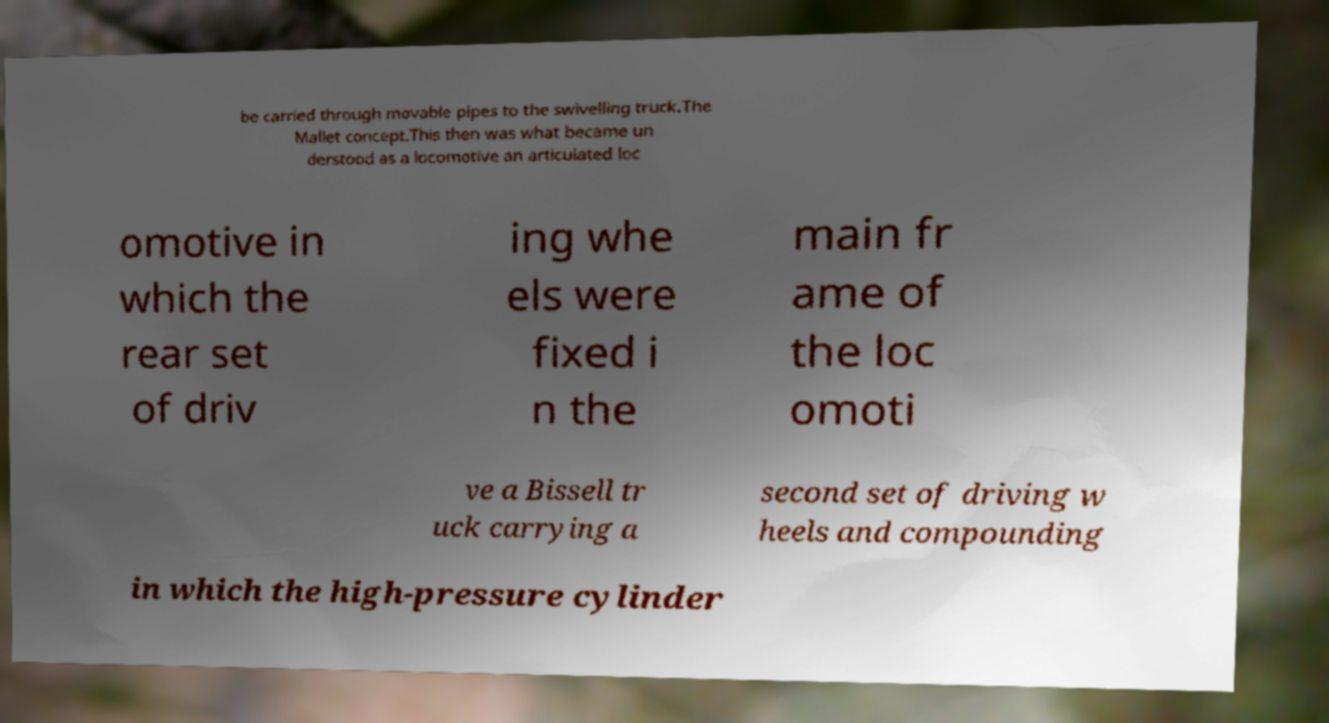Could you extract and type out the text from this image? be carried through movable pipes to the swivelling truck.The Mallet concept.This then was what became un derstood as a locomotive an articulated loc omotive in which the rear set of driv ing whe els were fixed i n the main fr ame of the loc omoti ve a Bissell tr uck carrying a second set of driving w heels and compounding in which the high-pressure cylinder 